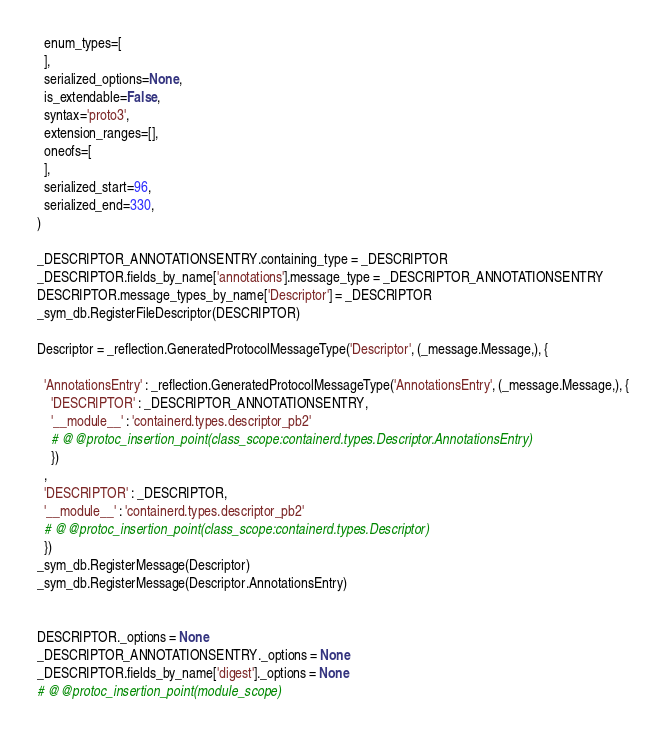Convert code to text. <code><loc_0><loc_0><loc_500><loc_500><_Python_>  enum_types=[
  ],
  serialized_options=None,
  is_extendable=False,
  syntax='proto3',
  extension_ranges=[],
  oneofs=[
  ],
  serialized_start=96,
  serialized_end=330,
)

_DESCRIPTOR_ANNOTATIONSENTRY.containing_type = _DESCRIPTOR
_DESCRIPTOR.fields_by_name['annotations'].message_type = _DESCRIPTOR_ANNOTATIONSENTRY
DESCRIPTOR.message_types_by_name['Descriptor'] = _DESCRIPTOR
_sym_db.RegisterFileDescriptor(DESCRIPTOR)

Descriptor = _reflection.GeneratedProtocolMessageType('Descriptor', (_message.Message,), {

  'AnnotationsEntry' : _reflection.GeneratedProtocolMessageType('AnnotationsEntry', (_message.Message,), {
    'DESCRIPTOR' : _DESCRIPTOR_ANNOTATIONSENTRY,
    '__module__' : 'containerd.types.descriptor_pb2'
    # @@protoc_insertion_point(class_scope:containerd.types.Descriptor.AnnotationsEntry)
    })
  ,
  'DESCRIPTOR' : _DESCRIPTOR,
  '__module__' : 'containerd.types.descriptor_pb2'
  # @@protoc_insertion_point(class_scope:containerd.types.Descriptor)
  })
_sym_db.RegisterMessage(Descriptor)
_sym_db.RegisterMessage(Descriptor.AnnotationsEntry)


DESCRIPTOR._options = None
_DESCRIPTOR_ANNOTATIONSENTRY._options = None
_DESCRIPTOR.fields_by_name['digest']._options = None
# @@protoc_insertion_point(module_scope)
</code> 